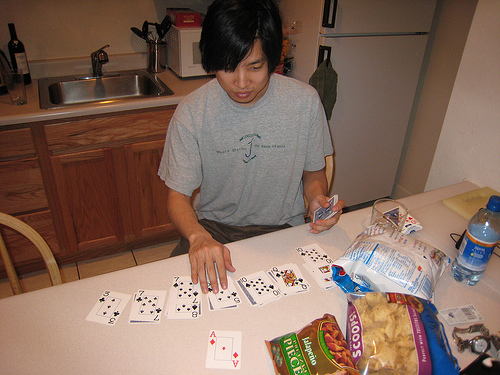<image>
Is the water bottle in front of the fridge? Yes. The water bottle is positioned in front of the fridge, appearing closer to the camera viewpoint. 